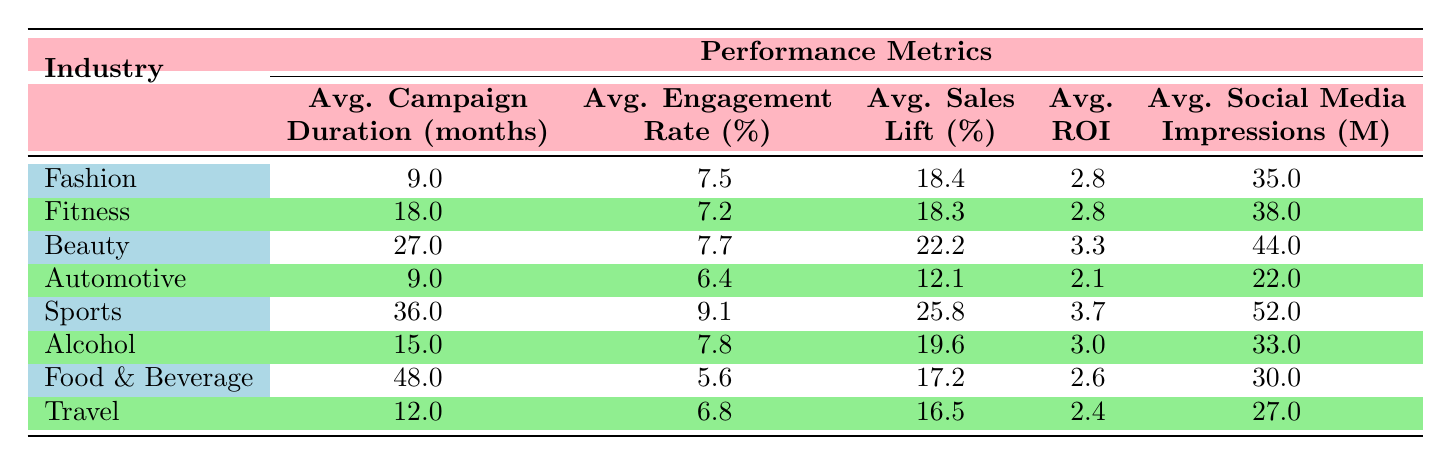What is the industry with the highest average ROI? The table shows that the industry with the highest average ROI is Sports with an average ROI of 3.7.
Answer: Sports What is the average sales lift for the Beauty industry? From the table, the average sales lift for the Beauty industry is 22.2%.
Answer: 22.2% Is the average engagement rate for Fashion higher than that for Automotive? The average engagement rate for Fashion is 7.5% and for Automotive, it is 6.4%. Since 7.5% is greater than 6.4%, the statement is true.
Answer: Yes What is the sum of the average campaign durations for Fitness and Travel industries? The average campaign duration for Fitness is 18 months and for Travel is 12 months. Adding these together: 18 + 12 = 30 months.
Answer: 30 Which industry has the lowest average engagement rate? The table lists Food & Beverage as having the lowest average engagement rate of 5.6%.
Answer: Food & Beverage Is the average social media impressions for Alcohol greater than 30 million? The table shows that the average social media impressions for Alcohol is 33 million, which is greater than 30 million. Therefore, the statement is true.
Answer: Yes What is the difference in average sales lift between the Sports and Fitness industries? The average sales lift for Sports is 25.8% and for Fitness is 18.3%. The difference is calculated as follows: 25.8 - 18.3 = 7.5%.
Answer: 7.5 Which industry has the highest average campaign duration? The table indicates that the Food & Beverage industry has the highest average campaign duration of 48 months.
Answer: Food & Beverage What is the average engagement rate across all industries? To find the average engagement rate, we sum all the engagement rates (8.7 + 7.2 + 5.9 + 6.4 + 9.1 + 7.8 + 5.6 + 6.8) and divide by the number of industries, which is 8. The total engagement rate sum is 57.5, and then 57.5 / 8 = 7.1875%, rounded to 7.2%.
Answer: 7.2 